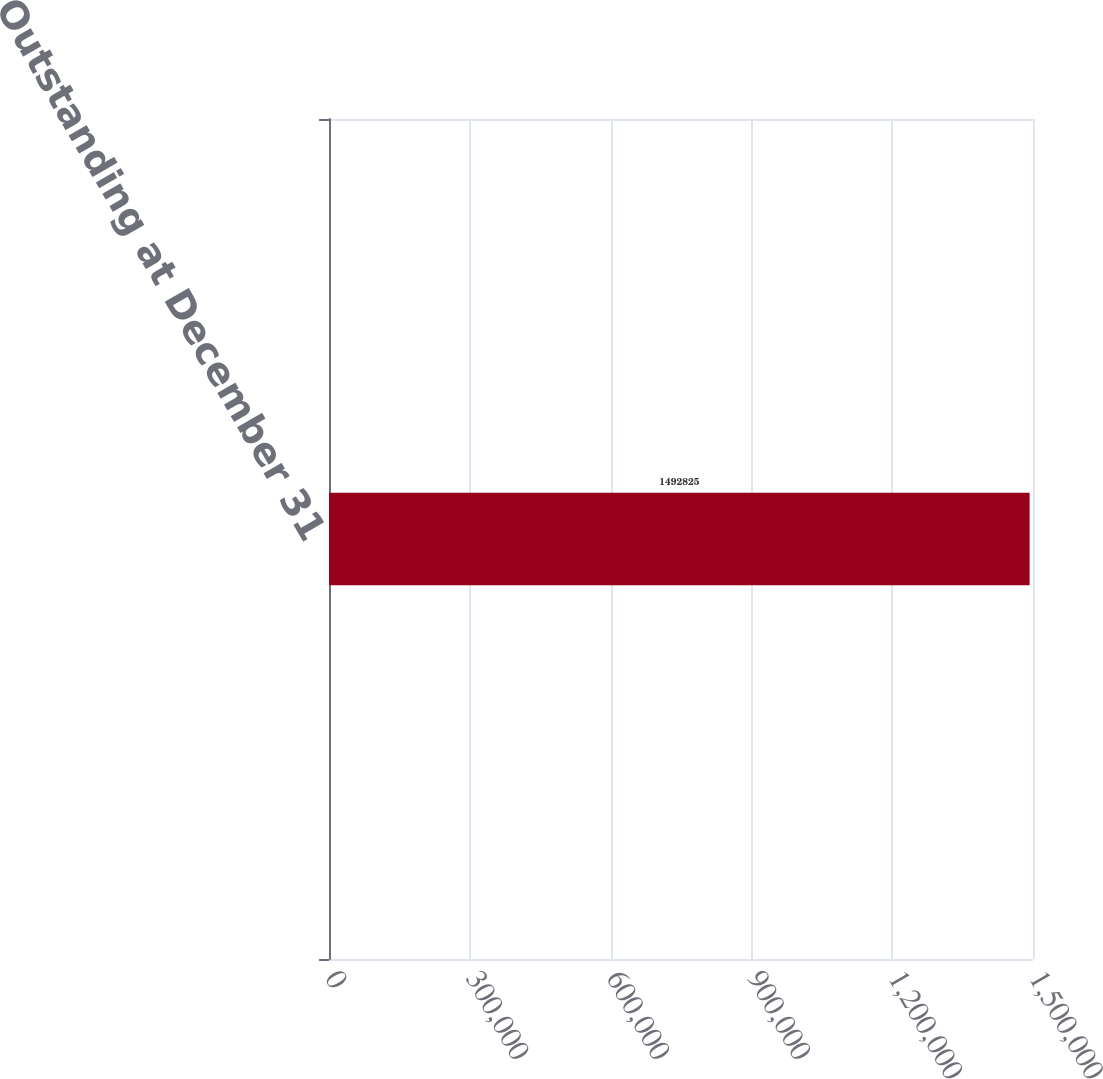Convert chart to OTSL. <chart><loc_0><loc_0><loc_500><loc_500><bar_chart><fcel>Outstanding at December 31<nl><fcel>1.49282e+06<nl></chart> 